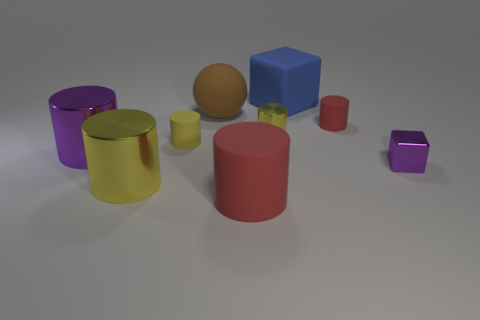Is there a red thing that has the same material as the blue thing?
Your answer should be very brief. Yes. What is the size of the object that is the same color as the tiny metallic cube?
Give a very brief answer. Large. What color is the tiny metallic thing to the left of the matte cube?
Make the answer very short. Yellow. Is the shape of the small purple metallic object the same as the yellow thing in front of the metal cube?
Your answer should be very brief. No. Is there a large metal cylinder that has the same color as the small shiny block?
Your answer should be very brief. Yes. The yellow object that is the same material as the large brown thing is what size?
Provide a succinct answer. Small. Is the shape of the purple thing left of the brown ball the same as  the yellow rubber object?
Your answer should be very brief. Yes. How many blue blocks are the same size as the brown matte thing?
Your answer should be very brief. 1. What shape is the tiny matte thing that is the same color as the large rubber cylinder?
Ensure brevity in your answer.  Cylinder. Are there any cylinders behind the yellow metallic cylinder that is to the left of the tiny shiny cylinder?
Offer a very short reply. Yes. 